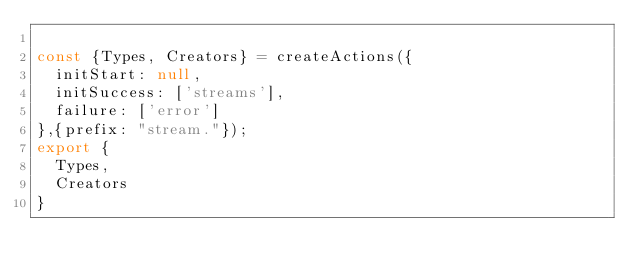Convert code to text. <code><loc_0><loc_0><loc_500><loc_500><_JavaScript_>
const {Types, Creators} = createActions({
  initStart: null,
  initSuccess: ['streams'],
  failure: ['error']
},{prefix: "stream."});
export {
  Types,
  Creators
}
</code> 